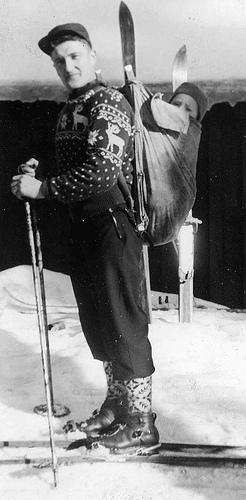How many people are in the picture?
Give a very brief answer. 2. 